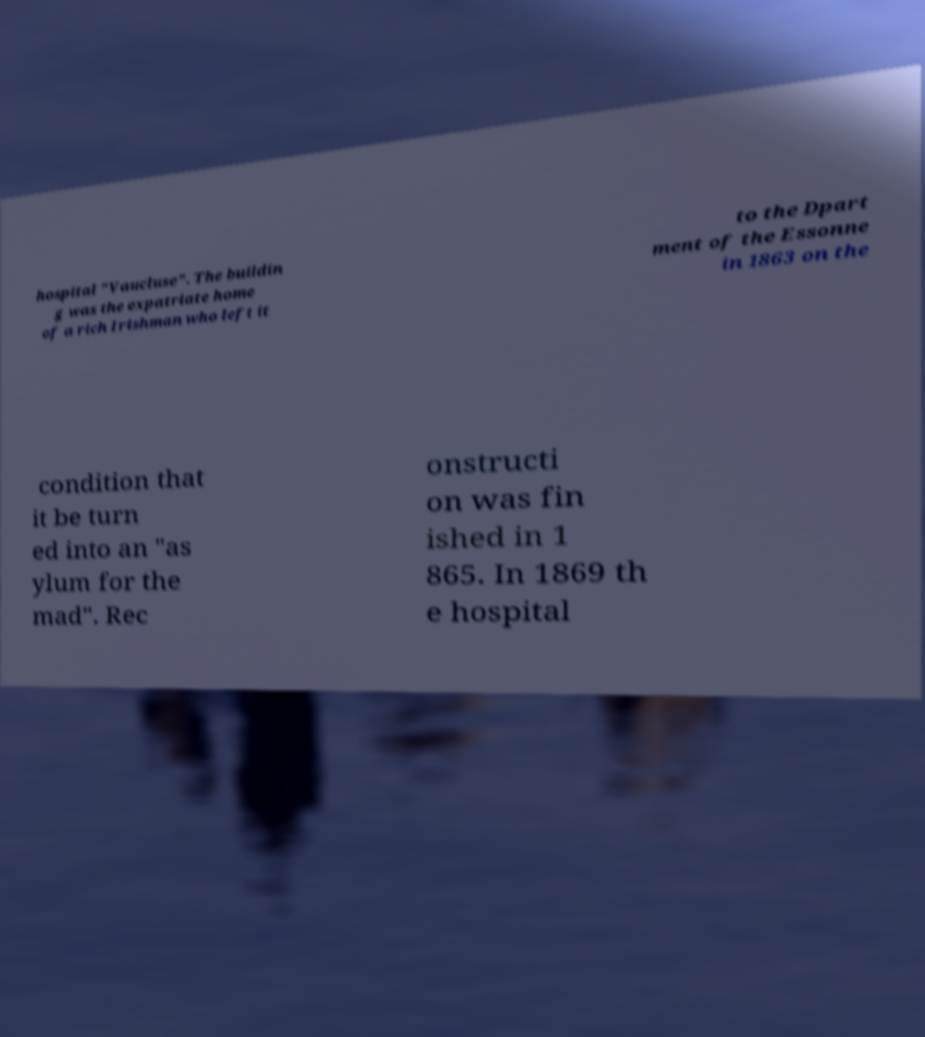For documentation purposes, I need the text within this image transcribed. Could you provide that? hospital "Vaucluse". The buildin g was the expatriate home of a rich Irishman who left it to the Dpart ment of the Essonne in 1863 on the condition that it be turn ed into an "as ylum for the mad". Rec onstructi on was fin ished in 1 865. In 1869 th e hospital 